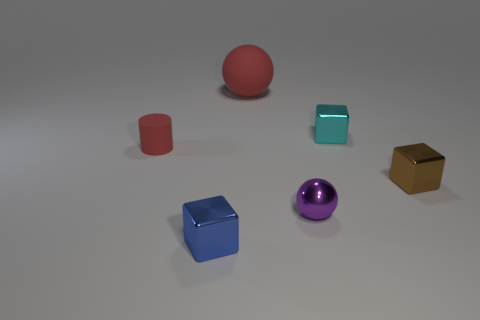Add 1 cyan things. How many objects exist? 7 Subtract all spheres. How many objects are left? 4 Add 4 tiny gray blocks. How many tiny gray blocks exist? 4 Subtract 0 gray balls. How many objects are left? 6 Subtract all tiny red blocks. Subtract all matte objects. How many objects are left? 4 Add 3 blue metal things. How many blue metal things are left? 4 